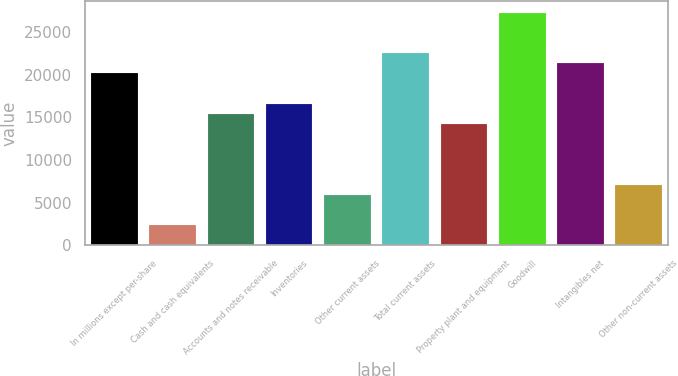Convert chart to OTSL. <chart><loc_0><loc_0><loc_500><loc_500><bar_chart><fcel>In millions except per-share<fcel>Cash and cash equivalents<fcel>Accounts and notes receivable<fcel>Inventories<fcel>Other current assets<fcel>Total current assets<fcel>Property plant and equipment<fcel>Goodwill<fcel>Intangibles net<fcel>Other non-current assets<nl><fcel>20156.4<fcel>2371.96<fcel>15413.9<fcel>16599.5<fcel>5928.85<fcel>22527.7<fcel>14228.3<fcel>27270.2<fcel>21342<fcel>7114.48<nl></chart> 